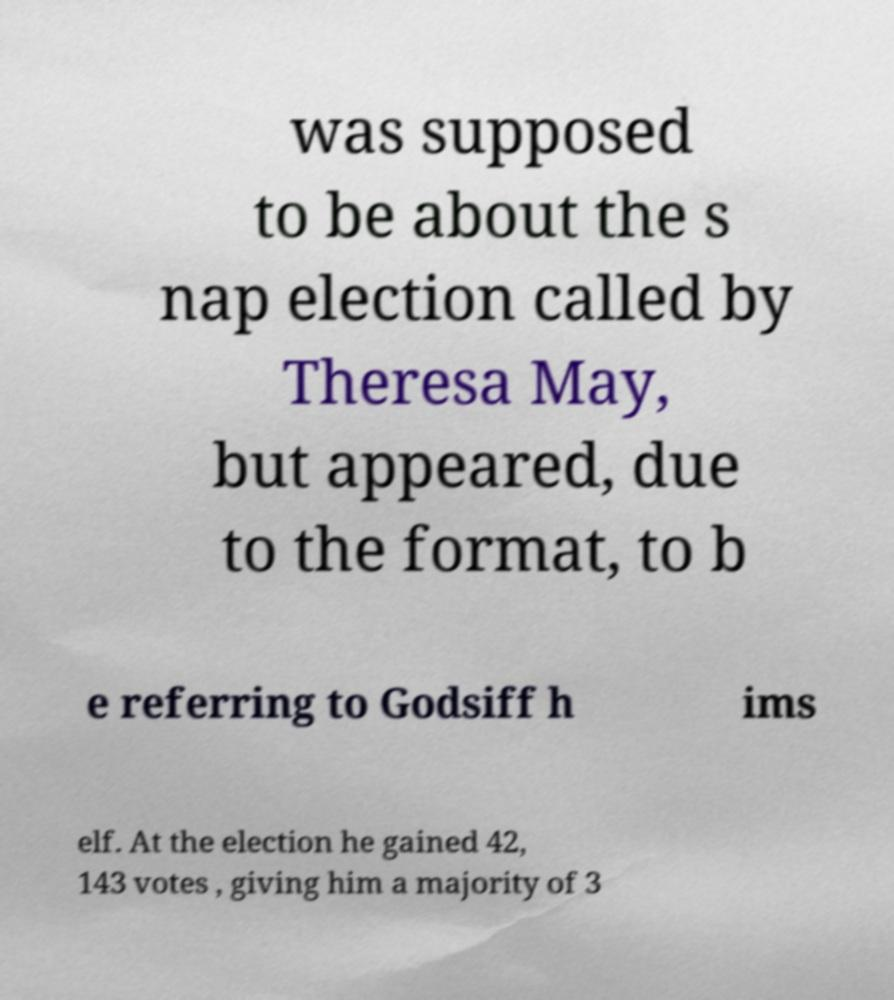Please read and relay the text visible in this image. What does it say? was supposed to be about the s nap election called by Theresa May, but appeared, due to the format, to b e referring to Godsiff h ims elf. At the election he gained 42, 143 votes , giving him a majority of 3 